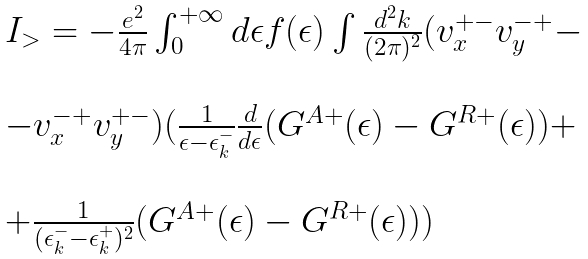<formula> <loc_0><loc_0><loc_500><loc_500>\begin{array} { l } I _ { > } = - \frac { e ^ { 2 } } { 4 \pi } \int _ { 0 } ^ { + \infty } d \epsilon f ( \epsilon ) \int \frac { d ^ { 2 } { k } } { ( 2 \pi ) ^ { 2 } } ( v _ { x } ^ { + - } v _ { y } ^ { - + } - \\ \\ - v _ { x } ^ { - + } v _ { y } ^ { + - } ) ( \frac { 1 } { \epsilon - \epsilon ^ { - } _ { k } } \frac { d } { d \epsilon } ( G ^ { A + } ( \epsilon ) - G ^ { R + } ( \epsilon ) ) + \\ \\ + \frac { 1 } { ( \epsilon ^ { - } _ { k } - \epsilon ^ { + } _ { k } ) ^ { 2 } } ( G ^ { A + } ( \epsilon ) - G ^ { R + } ( \epsilon ) ) ) \end{array}</formula> 